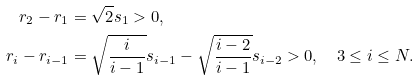Convert formula to latex. <formula><loc_0><loc_0><loc_500><loc_500>r _ { 2 } - r _ { 1 } & = \sqrt { 2 } s _ { 1 } > 0 , \\ r _ { i } - r _ { i - 1 } & = \sqrt { \frac { i } { i - 1 } } s _ { i - 1 } - \sqrt { \frac { i - 2 } { i - 1 } } s _ { i - 2 } > 0 , \quad 3 \leq i \leq N .</formula> 